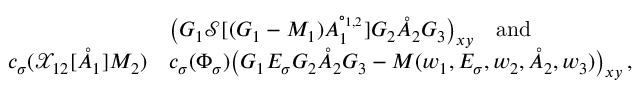<formula> <loc_0><loc_0><loc_500><loc_500>\begin{array} { r l } & { \left ( G _ { 1 } \mathcal { S } [ ( G _ { 1 } - M _ { 1 } ) A _ { 1 } ^ { \circ _ { 1 , 2 } } ] G _ { 2 } \mathring { A } _ { 2 } G _ { 3 } \right ) _ { x y } \quad a n d } \\ { c _ { \sigma } ( \mathcal { X } _ { 1 2 } [ \mathring { A } _ { 1 } ] M _ { 2 } ) } & { c _ { \sigma } ( \Phi _ { \sigma } ) \left ( G _ { 1 } E _ { \sigma } G _ { 2 } \mathring { A } _ { 2 } G _ { 3 } - M ( w _ { 1 } , E _ { \sigma } , w _ { 2 } , \mathring { A } _ { 2 } , w _ { 3 } ) \right ) _ { x y } \, , } \end{array}</formula> 